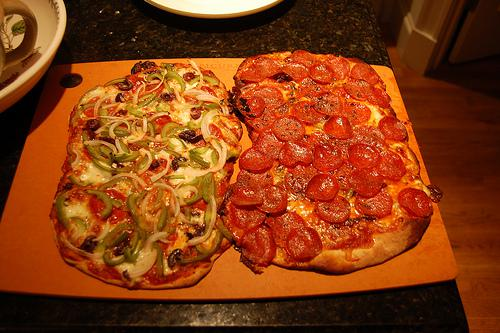Question: who is present?
Choices:
A. Nobody.
B. A man.
C. A woman.
D. A child.
Answer with the letter. Answer: A Question: what are they for?
Choices:
A. Eating.
B. Decoration.
C. To use.
D. To laugh at.
Answer with the letter. Answer: A 